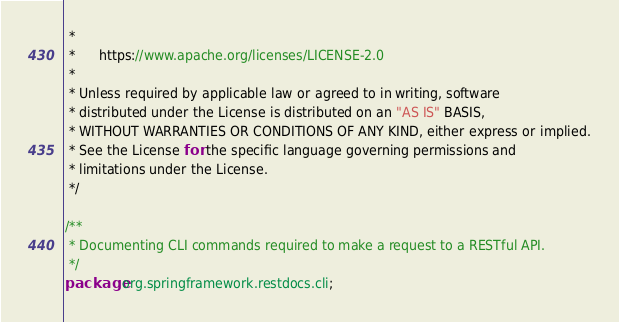Convert code to text. <code><loc_0><loc_0><loc_500><loc_500><_Java_> *
 *      https://www.apache.org/licenses/LICENSE-2.0
 *
 * Unless required by applicable law or agreed to in writing, software
 * distributed under the License is distributed on an "AS IS" BASIS,
 * WITHOUT WARRANTIES OR CONDITIONS OF ANY KIND, either express or implied.
 * See the License for the specific language governing permissions and
 * limitations under the License.
 */

/**
 * Documenting CLI commands required to make a request to a RESTful API.
 */
package org.springframework.restdocs.cli;
</code> 